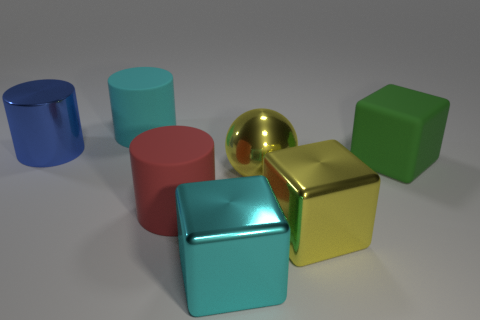Subtract all metallic cylinders. How many cylinders are left? 2 Subtract all brown cubes. Subtract all purple balls. How many cubes are left? 3 Add 1 large cyan things. How many objects exist? 8 Subtract all spheres. How many objects are left? 6 Add 6 cyan objects. How many cyan objects exist? 8 Subtract 1 cyan cylinders. How many objects are left? 6 Subtract all purple metal balls. Subtract all shiny blocks. How many objects are left? 5 Add 7 red rubber things. How many red rubber things are left? 8 